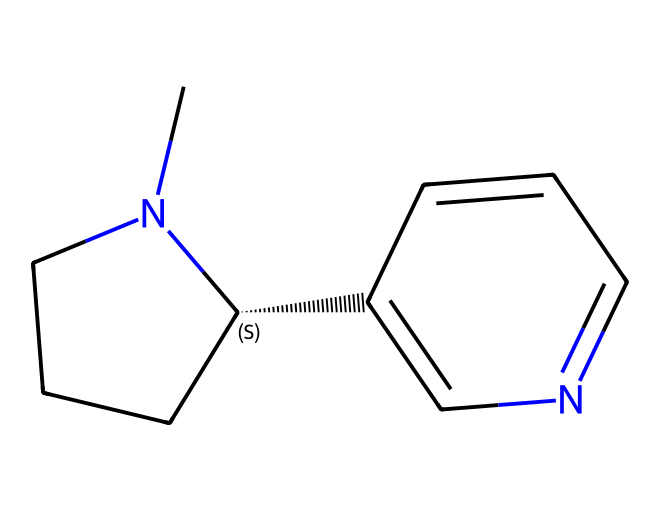What is the name of this chemical? The SMILES representation corresponds to nicotine, which is a well-known alkaloid commonly found in tobacco.
Answer: nicotine How many carbon atoms are present in the structure? By analyzing the SMILES representation, we can count the carbon atoms (C). There are 10 carbon atoms in nicotine's molecular structure.
Answer: 10 What type of chemical bond connects the atoms in this structure? The molecular structure features covalent bonds, specifically involving the sharing of electrons between the carbon, hydrogen, and nitrogen atoms.
Answer: covalent Is nicotine classified as a polar or nonpolar molecule? Given the presence of nitrogen atoms, which can create polarity by attracting electrons, nicotine is classified as a polar molecule.
Answer: polar Which part of the molecule contains the nitrogen atoms? The structure of nicotine shows nitrogen atoms incorporated in the central ring structure, specifically in the piperidine and pyridine rings.
Answer: the central ring What physiological effects does nicotine generally produce? Nicotine is known to stimulate the nervous system, leading to effects like increased heart rate and alertness.
Answer: stimulant effect Why might nicotine affect air quality near water recreation areas? As an alkaloid found in cigarette smoke, nicotine can be released into the environment, potentially affecting air quality through smoke emissions and water runoff.
Answer: affects air quality 